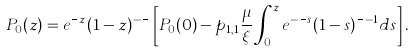<formula> <loc_0><loc_0><loc_500><loc_500>P _ { 0 } ( z ) = e ^ { \frac { \lambda } { \xi } z } ( 1 - z ) ^ { - \frac { \gamma } { \xi } } \left [ P _ { 0 } ( 0 ) - p _ { 1 , 1 } \frac { \mu } { \xi } \int _ { 0 } ^ { z } e ^ { - \frac { \lambda } { \xi } s } ( 1 - s ) ^ { \frac { \gamma } { \xi } - 1 } d s \right ] .</formula> 